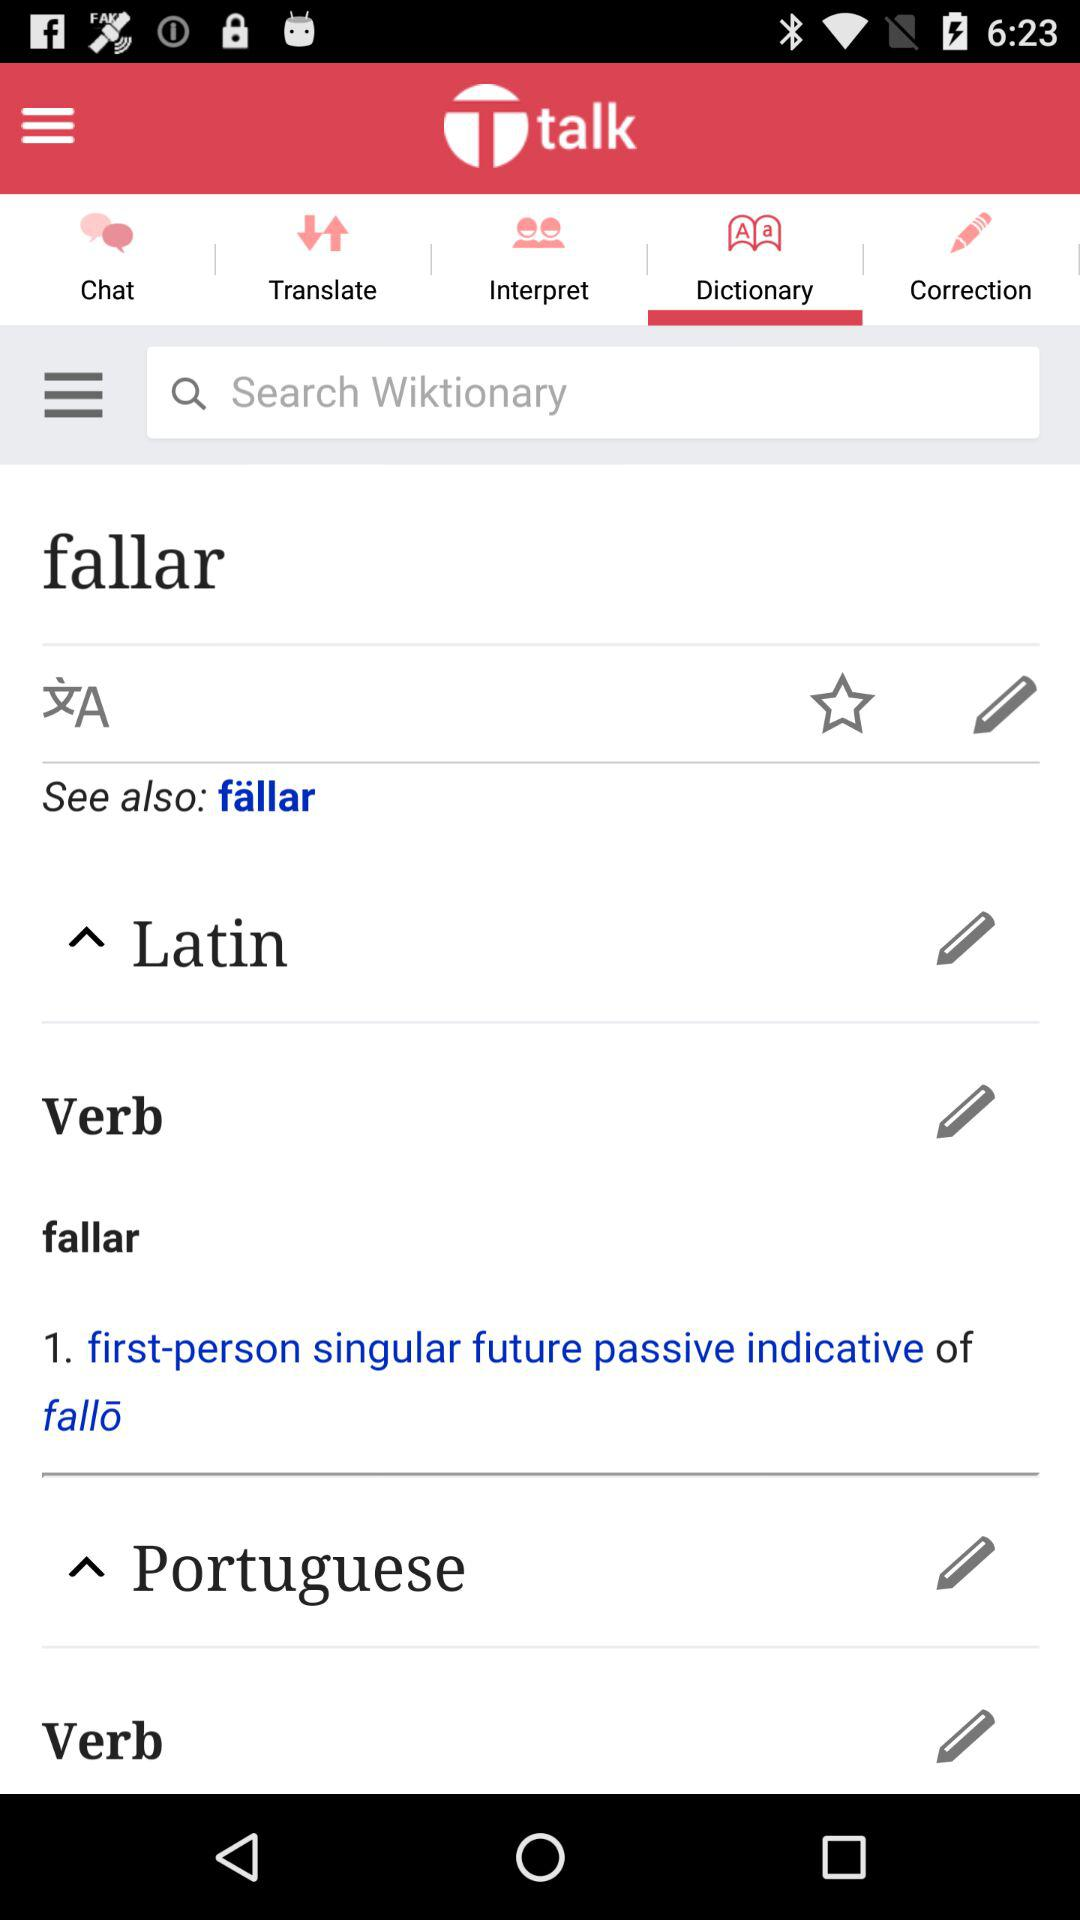What is the selected tab? The selected tab is "Dictionary". 